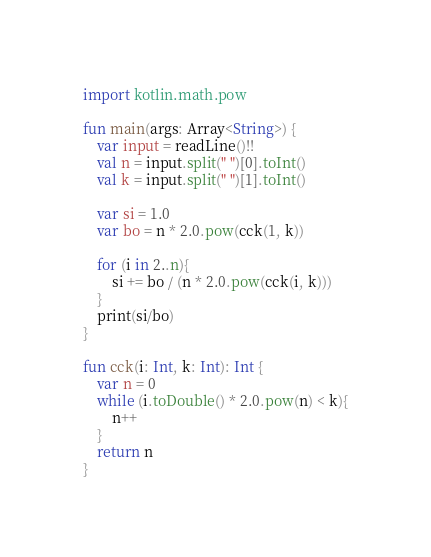<code> <loc_0><loc_0><loc_500><loc_500><_Kotlin_>import kotlin.math.pow

fun main(args: Array<String>) {
    var input = readLine()!!
    val n = input.split(" ")[0].toInt()
    val k = input.split(" ")[1].toInt()

    var si = 1.0
    var bo = n * 2.0.pow(cck(1, k))

    for (i in 2..n){
        si += bo / (n * 2.0.pow(cck(i, k)))
    }
    print(si/bo)
}

fun cck(i: Int, k: Int): Int {
    var n = 0
    while (i.toDouble() * 2.0.pow(n) < k){
        n++
    }
    return n
}
</code> 